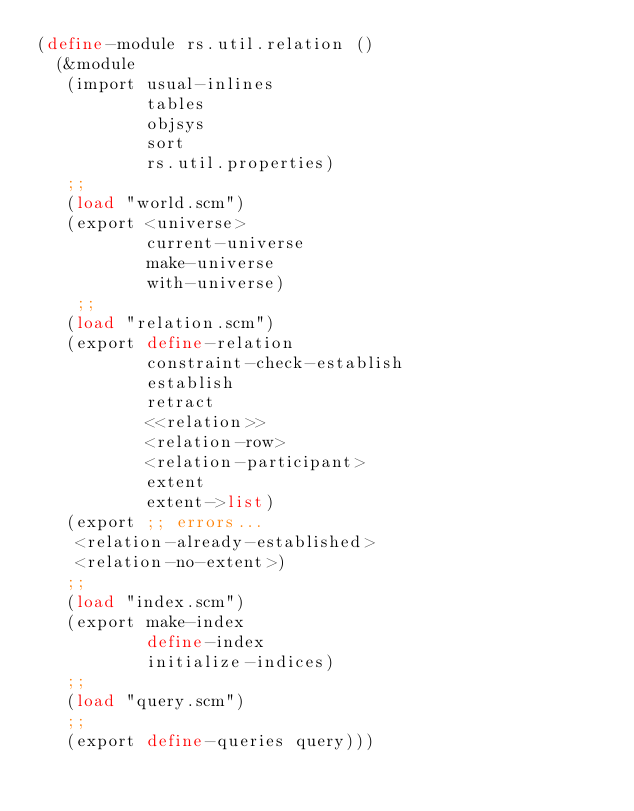<code> <loc_0><loc_0><loc_500><loc_500><_Scheme_>(define-module rs.util.relation ()
  (&module
   (import usual-inlines
           tables
           objsys
           sort
           rs.util.properties)
   ;;
   (load "world.scm")
   (export <universe>
           current-universe
           make-universe
           with-universe)
    ;;
   (load "relation.scm")
   (export define-relation
           constraint-check-establish
           establish
           retract
           <<relation>>
           <relation-row>
           <relation-participant>
           extent
           extent->list)
   (export ;; errors...
    <relation-already-established>
    <relation-no-extent>)
   ;;
   (load "index.scm")
   (export make-index 
           define-index
           initialize-indices)
   ;;
   (load "query.scm")
   ;;
   (export define-queries query)))
    
</code> 